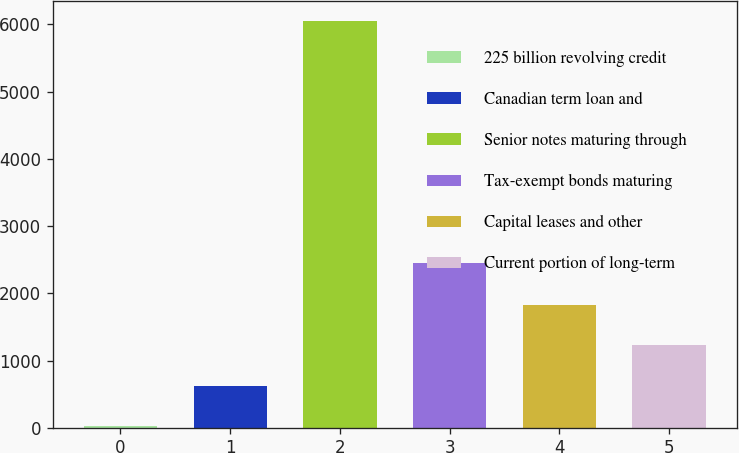Convert chart to OTSL. <chart><loc_0><loc_0><loc_500><loc_500><bar_chart><fcel>225 billion revolving credit<fcel>Canadian term loan and<fcel>Senior notes maturing through<fcel>Tax-exempt bonds maturing<fcel>Capital leases and other<fcel>Current portion of long-term<nl><fcel>20<fcel>623<fcel>6050<fcel>2447<fcel>1829<fcel>1226<nl></chart> 